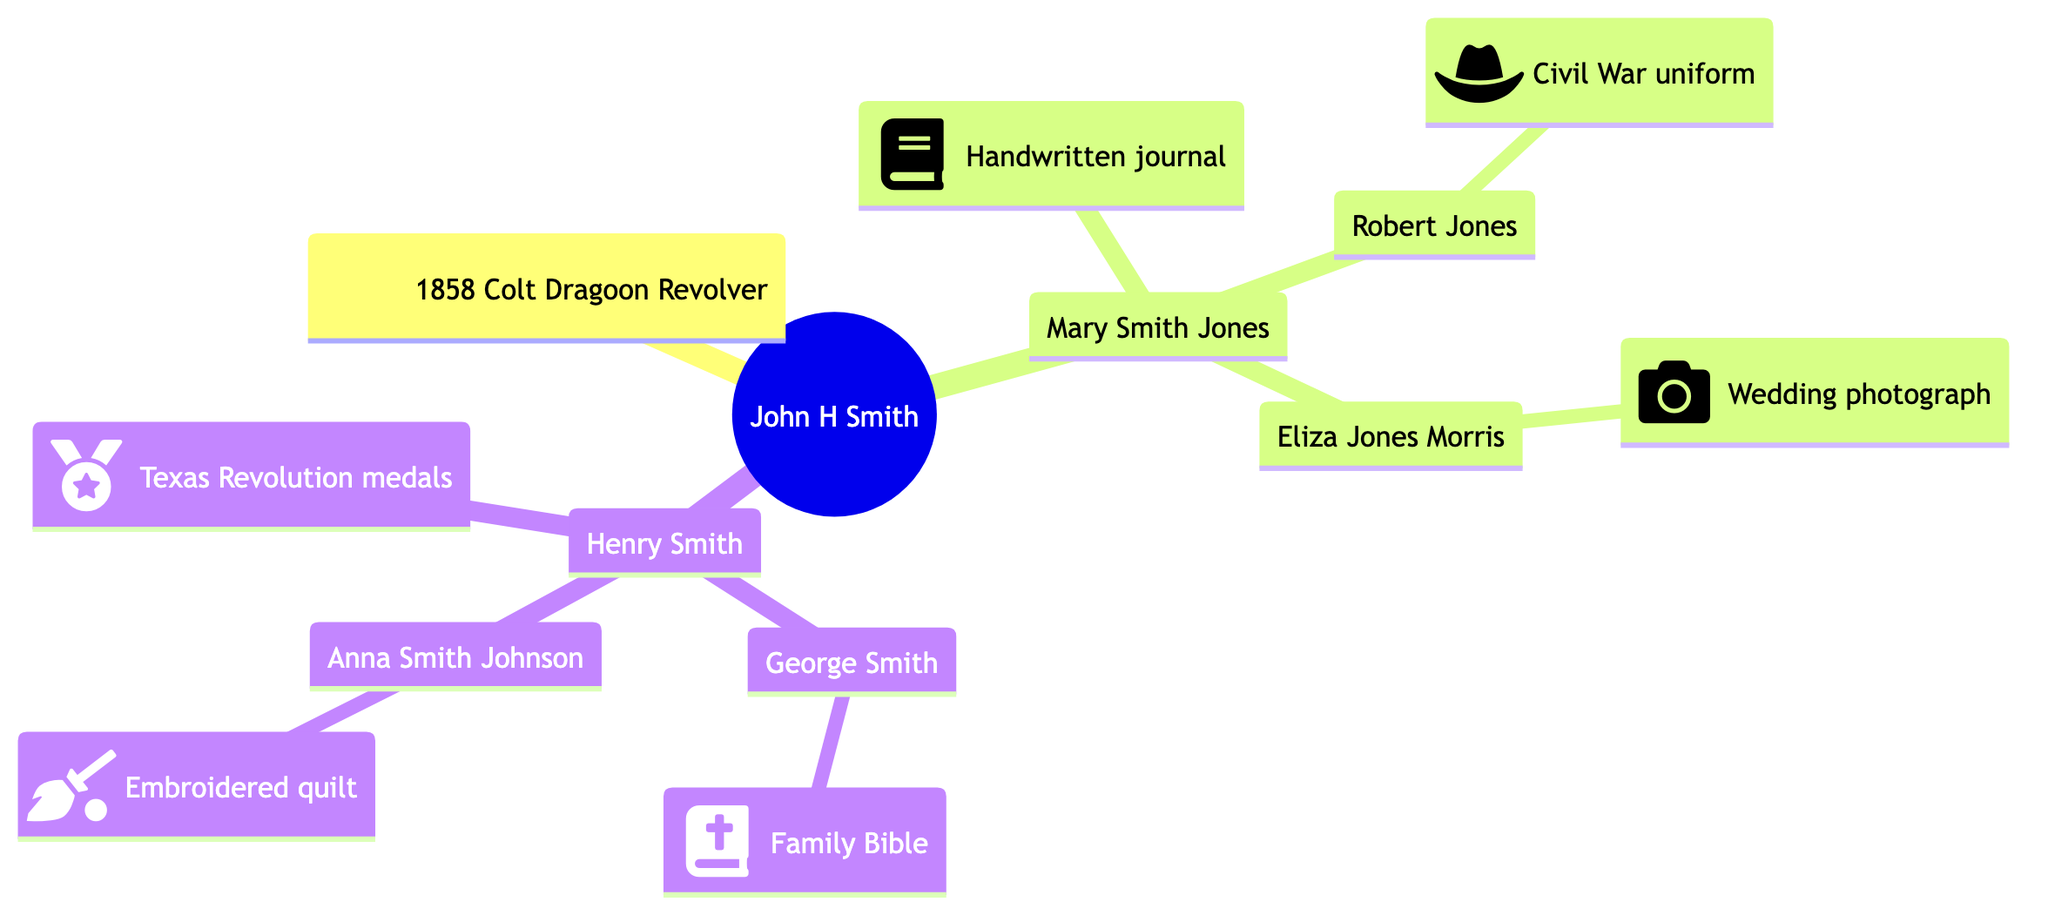What artifact did John H Smith contribute? The diagram states that John H Smith contributed the "1858 Colt Dragoon Revolver." This can be directly found in the node corresponding to him.
Answer: 1858 Colt Dragoon Revolver Who is the descendant of John H Smith that contributed a handwritten journal? The diagram shows that Mary Smith Jones is a descendant of John H Smith and contributed a "Handwritten journal." This relationship is clear in the lineage structure depicted.
Answer: Mary Smith Jones How many descendants does John H Smith have? By observing the diagram, John H Smith has two descendants listed (Mary Smith Jones and Henry Smith). Counting them gives the total number of descendants.
Answer: 2 What is the artifact contributed by Anna Smith Johnson? The node for Anna Smith Johnson indicates that she contributed an "Embroidered quilt." This is found by following the lineage down to her specific node.
Answer: Embroidered quilt Which descendant contributed a Civil War uniform? The diagram indicates Robert Jones, a descendant of Mary Smith Jones, contributed a "Civil War uniform." This requires following the family tree down to the specific child and their contributed artifact.
Answer: Civil War uniform Which artifact is contributed by Henry Smith? According to the diagram, Henry Smith contributed "Texas Revolution medals." This can be seen directly under his name in the family tree.
Answer: Texas Revolution medals How many total artifacts are represented in the diagram? The diagram shows each individual with their respective artifacts. Counting these, there are five distinct artifacts (one from each person).
Answer: 5 What is the relationship between Robert Jones and Mary Smith Jones? The diagram illustrates that Robert Jones is the son of Mary Smith Jones, establishing a direct parent-child relationship.
Answer: Son Which artifact did Eliza Jones Morris contribute? The diagram lists that Eliza Jones Morris contributed a "Wedding photograph." This is evident under her name as part of the family tree.
Answer: Wedding photograph 